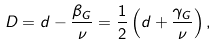<formula> <loc_0><loc_0><loc_500><loc_500>D = d - \frac { \beta _ { G } } { \nu } = \frac { 1 } { 2 } \left ( d + \frac { \gamma _ { G } } { \nu } \right ) ,</formula> 